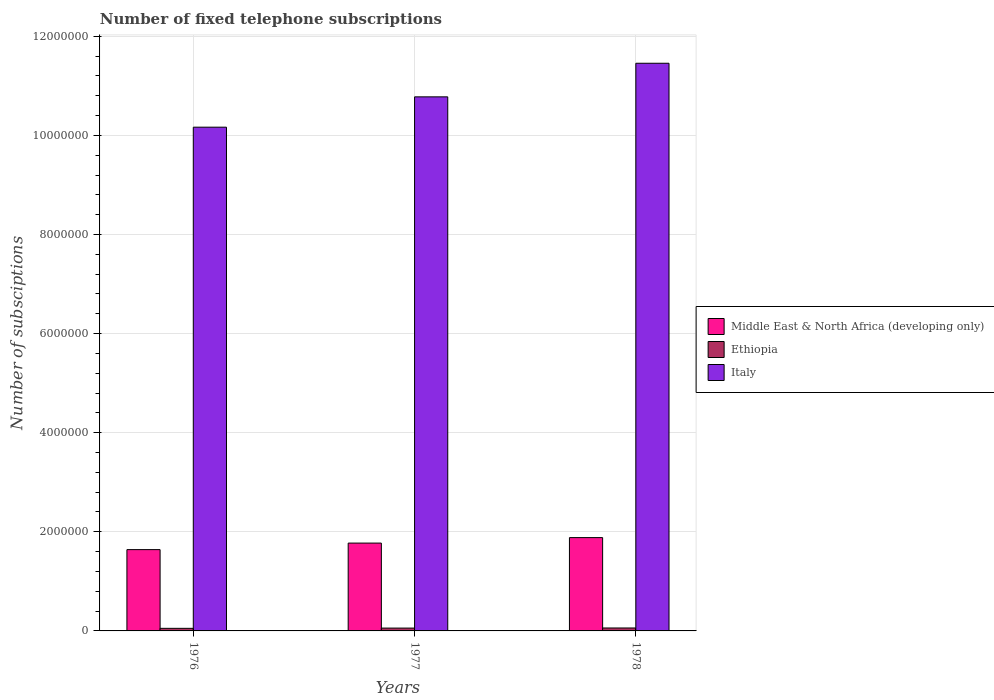How many different coloured bars are there?
Keep it short and to the point. 3. Are the number of bars on each tick of the X-axis equal?
Keep it short and to the point. Yes. How many bars are there on the 2nd tick from the left?
Provide a short and direct response. 3. What is the label of the 1st group of bars from the left?
Provide a short and direct response. 1976. In how many cases, is the number of bars for a given year not equal to the number of legend labels?
Provide a short and direct response. 0. What is the number of fixed telephone subscriptions in Italy in 1978?
Make the answer very short. 1.15e+07. Across all years, what is the maximum number of fixed telephone subscriptions in Italy?
Give a very brief answer. 1.15e+07. Across all years, what is the minimum number of fixed telephone subscriptions in Ethiopia?
Provide a short and direct response. 5.21e+04. In which year was the number of fixed telephone subscriptions in Italy maximum?
Offer a terse response. 1978. In which year was the number of fixed telephone subscriptions in Middle East & North Africa (developing only) minimum?
Provide a short and direct response. 1976. What is the total number of fixed telephone subscriptions in Italy in the graph?
Provide a short and direct response. 3.24e+07. What is the difference between the number of fixed telephone subscriptions in Middle East & North Africa (developing only) in 1977 and that in 1978?
Offer a very short reply. -1.11e+05. What is the difference between the number of fixed telephone subscriptions in Italy in 1977 and the number of fixed telephone subscriptions in Middle East & North Africa (developing only) in 1976?
Ensure brevity in your answer.  9.14e+06. What is the average number of fixed telephone subscriptions in Ethiopia per year?
Make the answer very short. 5.62e+04. In the year 1976, what is the difference between the number of fixed telephone subscriptions in Italy and number of fixed telephone subscriptions in Middle East & North Africa (developing only)?
Your answer should be very brief. 8.53e+06. In how many years, is the number of fixed telephone subscriptions in Ethiopia greater than 2400000?
Provide a succinct answer. 0. What is the ratio of the number of fixed telephone subscriptions in Middle East & North Africa (developing only) in 1977 to that in 1978?
Give a very brief answer. 0.94. Is the difference between the number of fixed telephone subscriptions in Italy in 1977 and 1978 greater than the difference between the number of fixed telephone subscriptions in Middle East & North Africa (developing only) in 1977 and 1978?
Ensure brevity in your answer.  No. What is the difference between the highest and the second highest number of fixed telephone subscriptions in Italy?
Give a very brief answer. 6.78e+05. What is the difference between the highest and the lowest number of fixed telephone subscriptions in Italy?
Keep it short and to the point. 1.29e+06. Is the sum of the number of fixed telephone subscriptions in Middle East & North Africa (developing only) in 1977 and 1978 greater than the maximum number of fixed telephone subscriptions in Italy across all years?
Give a very brief answer. No. What does the 2nd bar from the left in 1978 represents?
Your response must be concise. Ethiopia. What does the 3rd bar from the right in 1978 represents?
Make the answer very short. Middle East & North Africa (developing only). Is it the case that in every year, the sum of the number of fixed telephone subscriptions in Ethiopia and number of fixed telephone subscriptions in Middle East & North Africa (developing only) is greater than the number of fixed telephone subscriptions in Italy?
Offer a terse response. No. How many bars are there?
Offer a terse response. 9. Are all the bars in the graph horizontal?
Provide a succinct answer. No. How many years are there in the graph?
Provide a short and direct response. 3. What is the difference between two consecutive major ticks on the Y-axis?
Ensure brevity in your answer.  2.00e+06. Where does the legend appear in the graph?
Keep it short and to the point. Center right. How many legend labels are there?
Offer a terse response. 3. What is the title of the graph?
Offer a terse response. Number of fixed telephone subscriptions. What is the label or title of the X-axis?
Offer a terse response. Years. What is the label or title of the Y-axis?
Your response must be concise. Number of subsciptions. What is the Number of subsciptions in Middle East & North Africa (developing only) in 1976?
Make the answer very short. 1.64e+06. What is the Number of subsciptions in Ethiopia in 1976?
Give a very brief answer. 5.21e+04. What is the Number of subsciptions in Italy in 1976?
Ensure brevity in your answer.  1.02e+07. What is the Number of subsciptions in Middle East & North Africa (developing only) in 1977?
Provide a short and direct response. 1.77e+06. What is the Number of subsciptions in Ethiopia in 1977?
Your answer should be very brief. 5.72e+04. What is the Number of subsciptions of Italy in 1977?
Ensure brevity in your answer.  1.08e+07. What is the Number of subsciptions of Middle East & North Africa (developing only) in 1978?
Make the answer very short. 1.88e+06. What is the Number of subsciptions in Ethiopia in 1978?
Give a very brief answer. 5.93e+04. What is the Number of subsciptions of Italy in 1978?
Give a very brief answer. 1.15e+07. Across all years, what is the maximum Number of subsciptions in Middle East & North Africa (developing only)?
Keep it short and to the point. 1.88e+06. Across all years, what is the maximum Number of subsciptions of Ethiopia?
Offer a very short reply. 5.93e+04. Across all years, what is the maximum Number of subsciptions of Italy?
Provide a succinct answer. 1.15e+07. Across all years, what is the minimum Number of subsciptions in Middle East & North Africa (developing only)?
Provide a succinct answer. 1.64e+06. Across all years, what is the minimum Number of subsciptions in Ethiopia?
Your answer should be very brief. 5.21e+04. Across all years, what is the minimum Number of subsciptions of Italy?
Your answer should be compact. 1.02e+07. What is the total Number of subsciptions in Middle East & North Africa (developing only) in the graph?
Your answer should be compact. 5.30e+06. What is the total Number of subsciptions of Ethiopia in the graph?
Your response must be concise. 1.69e+05. What is the total Number of subsciptions in Italy in the graph?
Give a very brief answer. 3.24e+07. What is the difference between the Number of subsciptions in Middle East & North Africa (developing only) in 1976 and that in 1977?
Offer a very short reply. -1.32e+05. What is the difference between the Number of subsciptions in Ethiopia in 1976 and that in 1977?
Offer a very short reply. -5090. What is the difference between the Number of subsciptions in Italy in 1976 and that in 1977?
Your answer should be compact. -6.12e+05. What is the difference between the Number of subsciptions in Middle East & North Africa (developing only) in 1976 and that in 1978?
Give a very brief answer. -2.43e+05. What is the difference between the Number of subsciptions in Ethiopia in 1976 and that in 1978?
Keep it short and to the point. -7226. What is the difference between the Number of subsciptions of Italy in 1976 and that in 1978?
Provide a succinct answer. -1.29e+06. What is the difference between the Number of subsciptions in Middle East & North Africa (developing only) in 1977 and that in 1978?
Your answer should be very brief. -1.11e+05. What is the difference between the Number of subsciptions of Ethiopia in 1977 and that in 1978?
Keep it short and to the point. -2136. What is the difference between the Number of subsciptions in Italy in 1977 and that in 1978?
Ensure brevity in your answer.  -6.78e+05. What is the difference between the Number of subsciptions of Middle East & North Africa (developing only) in 1976 and the Number of subsciptions of Ethiopia in 1977?
Your response must be concise. 1.58e+06. What is the difference between the Number of subsciptions in Middle East & North Africa (developing only) in 1976 and the Number of subsciptions in Italy in 1977?
Provide a succinct answer. -9.14e+06. What is the difference between the Number of subsciptions in Ethiopia in 1976 and the Number of subsciptions in Italy in 1977?
Offer a very short reply. -1.07e+07. What is the difference between the Number of subsciptions in Middle East & North Africa (developing only) in 1976 and the Number of subsciptions in Ethiopia in 1978?
Your response must be concise. 1.58e+06. What is the difference between the Number of subsciptions of Middle East & North Africa (developing only) in 1976 and the Number of subsciptions of Italy in 1978?
Your answer should be compact. -9.82e+06. What is the difference between the Number of subsciptions in Ethiopia in 1976 and the Number of subsciptions in Italy in 1978?
Provide a short and direct response. -1.14e+07. What is the difference between the Number of subsciptions in Middle East & North Africa (developing only) in 1977 and the Number of subsciptions in Ethiopia in 1978?
Offer a very short reply. 1.71e+06. What is the difference between the Number of subsciptions of Middle East & North Africa (developing only) in 1977 and the Number of subsciptions of Italy in 1978?
Provide a succinct answer. -9.68e+06. What is the difference between the Number of subsciptions of Ethiopia in 1977 and the Number of subsciptions of Italy in 1978?
Provide a short and direct response. -1.14e+07. What is the average Number of subsciptions of Middle East & North Africa (developing only) per year?
Give a very brief answer. 1.77e+06. What is the average Number of subsciptions of Ethiopia per year?
Make the answer very short. 5.62e+04. What is the average Number of subsciptions of Italy per year?
Your answer should be very brief. 1.08e+07. In the year 1976, what is the difference between the Number of subsciptions of Middle East & North Africa (developing only) and Number of subsciptions of Ethiopia?
Ensure brevity in your answer.  1.59e+06. In the year 1976, what is the difference between the Number of subsciptions in Middle East & North Africa (developing only) and Number of subsciptions in Italy?
Your answer should be compact. -8.53e+06. In the year 1976, what is the difference between the Number of subsciptions in Ethiopia and Number of subsciptions in Italy?
Offer a very short reply. -1.01e+07. In the year 1977, what is the difference between the Number of subsciptions of Middle East & North Africa (developing only) and Number of subsciptions of Ethiopia?
Keep it short and to the point. 1.72e+06. In the year 1977, what is the difference between the Number of subsciptions in Middle East & North Africa (developing only) and Number of subsciptions in Italy?
Your answer should be very brief. -9.01e+06. In the year 1977, what is the difference between the Number of subsciptions in Ethiopia and Number of subsciptions in Italy?
Provide a short and direct response. -1.07e+07. In the year 1978, what is the difference between the Number of subsciptions of Middle East & North Africa (developing only) and Number of subsciptions of Ethiopia?
Offer a terse response. 1.82e+06. In the year 1978, what is the difference between the Number of subsciptions of Middle East & North Africa (developing only) and Number of subsciptions of Italy?
Your answer should be very brief. -9.57e+06. In the year 1978, what is the difference between the Number of subsciptions of Ethiopia and Number of subsciptions of Italy?
Your response must be concise. -1.14e+07. What is the ratio of the Number of subsciptions of Middle East & North Africa (developing only) in 1976 to that in 1977?
Your answer should be very brief. 0.93. What is the ratio of the Number of subsciptions in Ethiopia in 1976 to that in 1977?
Your response must be concise. 0.91. What is the ratio of the Number of subsciptions of Italy in 1976 to that in 1977?
Offer a terse response. 0.94. What is the ratio of the Number of subsciptions in Middle East & North Africa (developing only) in 1976 to that in 1978?
Your response must be concise. 0.87. What is the ratio of the Number of subsciptions in Ethiopia in 1976 to that in 1978?
Your answer should be very brief. 0.88. What is the ratio of the Number of subsciptions in Italy in 1976 to that in 1978?
Provide a succinct answer. 0.89. What is the ratio of the Number of subsciptions of Ethiopia in 1977 to that in 1978?
Keep it short and to the point. 0.96. What is the ratio of the Number of subsciptions in Italy in 1977 to that in 1978?
Your answer should be very brief. 0.94. What is the difference between the highest and the second highest Number of subsciptions in Middle East & North Africa (developing only)?
Keep it short and to the point. 1.11e+05. What is the difference between the highest and the second highest Number of subsciptions of Ethiopia?
Give a very brief answer. 2136. What is the difference between the highest and the second highest Number of subsciptions in Italy?
Offer a very short reply. 6.78e+05. What is the difference between the highest and the lowest Number of subsciptions of Middle East & North Africa (developing only)?
Your response must be concise. 2.43e+05. What is the difference between the highest and the lowest Number of subsciptions of Ethiopia?
Offer a very short reply. 7226. What is the difference between the highest and the lowest Number of subsciptions of Italy?
Your answer should be compact. 1.29e+06. 